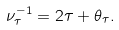Convert formula to latex. <formula><loc_0><loc_0><loc_500><loc_500>\nu _ { \tau } ^ { - 1 } = 2 \tau + \theta _ { \tau } .</formula> 